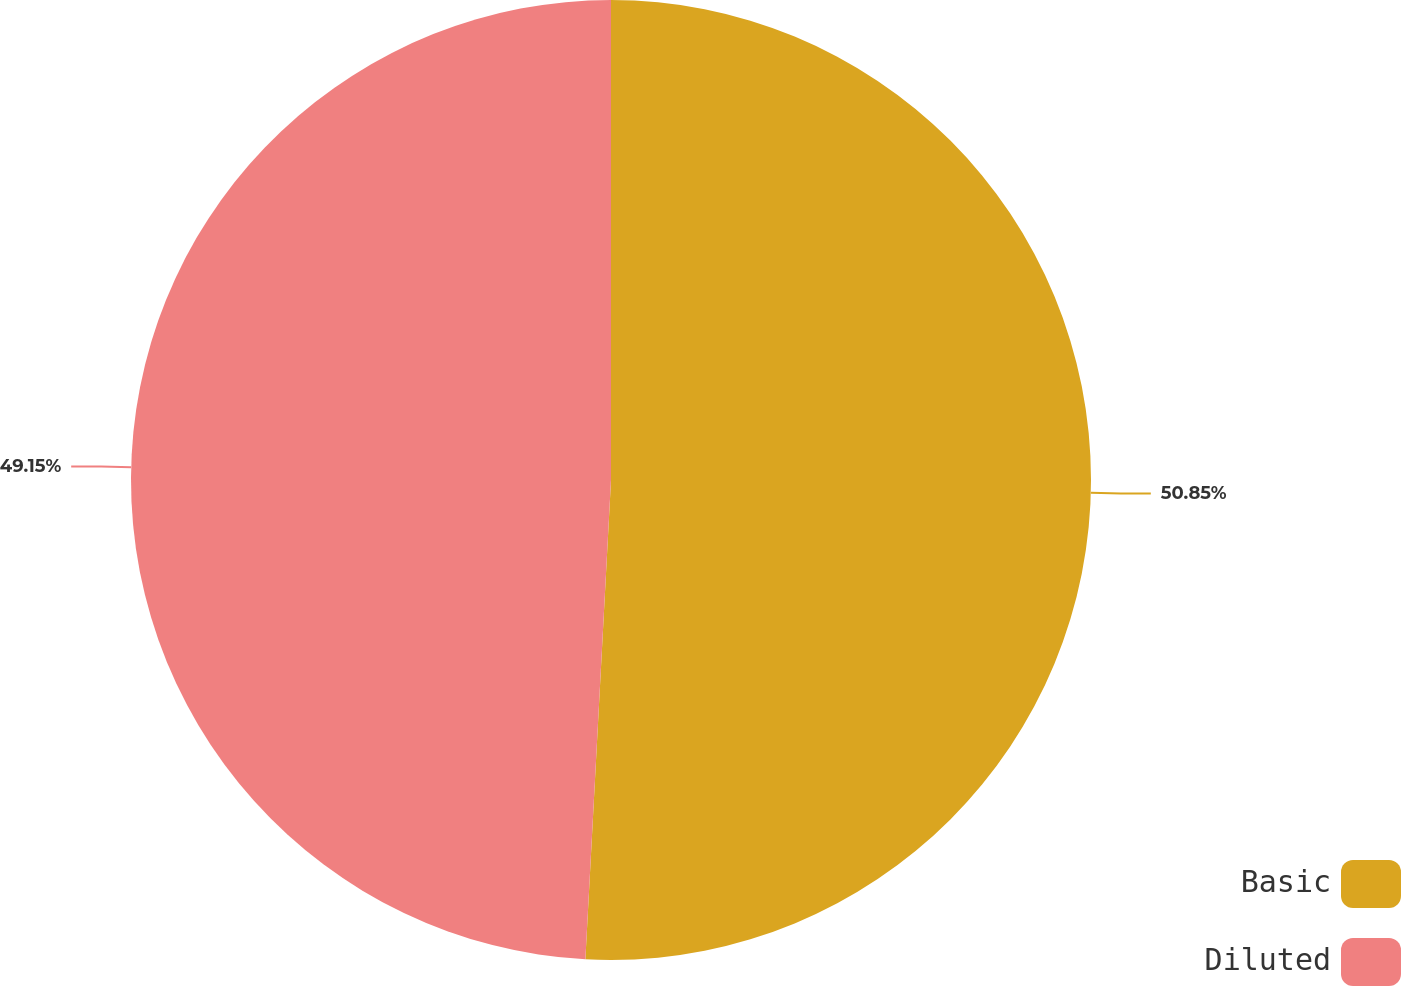<chart> <loc_0><loc_0><loc_500><loc_500><pie_chart><fcel>Basic<fcel>Diluted<nl><fcel>50.85%<fcel>49.15%<nl></chart> 